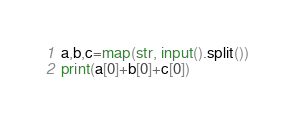<code> <loc_0><loc_0><loc_500><loc_500><_Python_>a,b,c=map(str, input().split())
print(a[0]+b[0]+c[0])</code> 